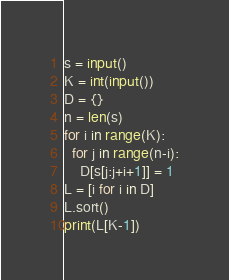<code> <loc_0><loc_0><loc_500><loc_500><_Python_>s = input()
K = int(input())
D = {}
n = len(s)
for i in range(K):
  for j in range(n-i):
    D[s[j:j+i+1]] = 1
L = [i for i in D]
L.sort()
print(L[K-1])</code> 